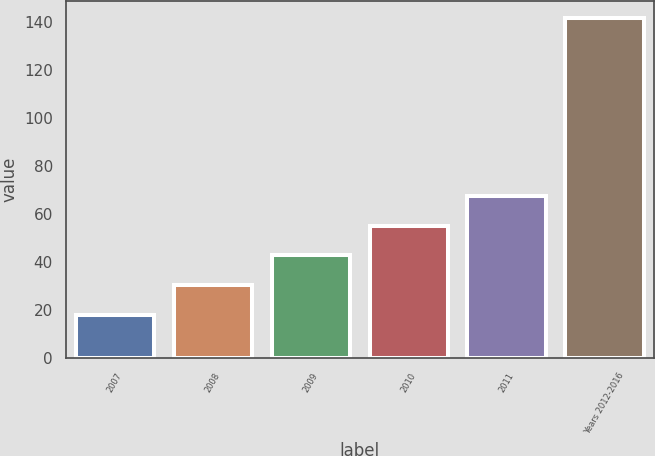<chart> <loc_0><loc_0><loc_500><loc_500><bar_chart><fcel>2007<fcel>2008<fcel>2009<fcel>2010<fcel>2011<fcel>Years 2012-2016<nl><fcel>18<fcel>30.36<fcel>42.72<fcel>55.08<fcel>67.44<fcel>141.6<nl></chart> 